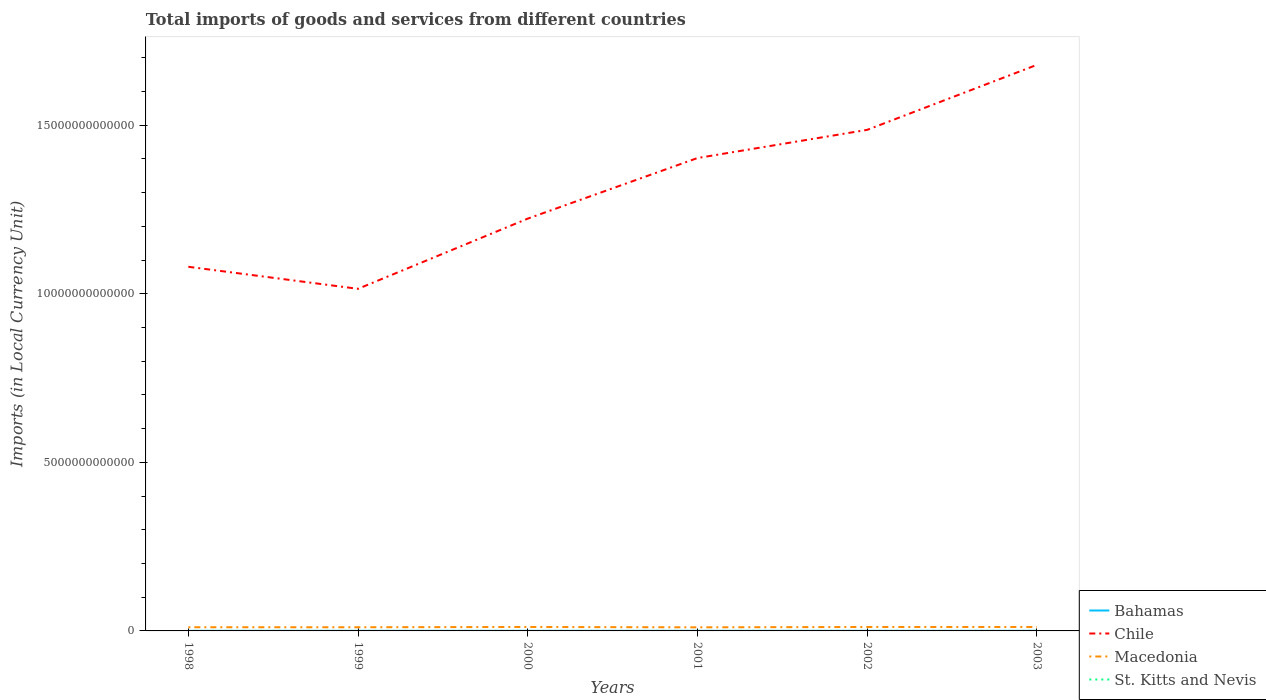How many different coloured lines are there?
Your answer should be compact. 4. Does the line corresponding to St. Kitts and Nevis intersect with the line corresponding to Macedonia?
Provide a short and direct response. No. Is the number of lines equal to the number of legend labels?
Offer a very short reply. Yes. Across all years, what is the maximum Amount of goods and services imports in Bahamas?
Offer a very short reply. 2.60e+09. In which year was the Amount of goods and services imports in Macedonia maximum?
Give a very brief answer. 2001. What is the total Amount of goods and services imports in St. Kitts and Nevis in the graph?
Your answer should be compact. -1.70e+08. What is the difference between the highest and the second highest Amount of goods and services imports in Macedonia?
Make the answer very short. 1.07e+1. Is the Amount of goods and services imports in Chile strictly greater than the Amount of goods and services imports in Macedonia over the years?
Your response must be concise. No. How many years are there in the graph?
Provide a short and direct response. 6. What is the difference between two consecutive major ticks on the Y-axis?
Offer a very short reply. 5.00e+12. Are the values on the major ticks of Y-axis written in scientific E-notation?
Your answer should be very brief. No. How are the legend labels stacked?
Your answer should be very brief. Vertical. What is the title of the graph?
Your response must be concise. Total imports of goods and services from different countries. Does "American Samoa" appear as one of the legend labels in the graph?
Provide a short and direct response. No. What is the label or title of the Y-axis?
Offer a very short reply. Imports (in Local Currency Unit). What is the Imports (in Local Currency Unit) in Bahamas in 1998?
Offer a very short reply. 2.60e+09. What is the Imports (in Local Currency Unit) of Chile in 1998?
Your answer should be very brief. 1.08e+13. What is the Imports (in Local Currency Unit) in Macedonia in 1998?
Offer a terse response. 1.09e+11. What is the Imports (in Local Currency Unit) of St. Kitts and Nevis in 1998?
Offer a terse response. 5.21e+08. What is the Imports (in Local Currency Unit) in Bahamas in 1999?
Your answer should be very brief. 2.66e+09. What is the Imports (in Local Currency Unit) in Chile in 1999?
Provide a short and direct response. 1.01e+13. What is the Imports (in Local Currency Unit) of Macedonia in 1999?
Ensure brevity in your answer.  1.09e+11. What is the Imports (in Local Currency Unit) of St. Kitts and Nevis in 1999?
Provide a short and direct response. 5.54e+08. What is the Imports (in Local Currency Unit) in Bahamas in 2000?
Offer a very short reply. 2.96e+09. What is the Imports (in Local Currency Unit) of Chile in 2000?
Ensure brevity in your answer.  1.22e+13. What is the Imports (in Local Currency Unit) in Macedonia in 2000?
Your answer should be very brief. 1.17e+11. What is the Imports (in Local Currency Unit) of St. Kitts and Nevis in 2000?
Ensure brevity in your answer.  6.72e+08. What is the Imports (in Local Currency Unit) of Bahamas in 2001?
Provide a succinct answer. 2.82e+09. What is the Imports (in Local Currency Unit) of Chile in 2001?
Your response must be concise. 1.40e+13. What is the Imports (in Local Currency Unit) of Macedonia in 2001?
Keep it short and to the point. 1.07e+11. What is the Imports (in Local Currency Unit) of St. Kitts and Nevis in 2001?
Give a very brief answer. 6.53e+08. What is the Imports (in Local Currency Unit) of Bahamas in 2002?
Your response must be concise. 2.67e+09. What is the Imports (in Local Currency Unit) of Chile in 2002?
Offer a very short reply. 1.49e+13. What is the Imports (in Local Currency Unit) in Macedonia in 2002?
Your response must be concise. 1.17e+11. What is the Imports (in Local Currency Unit) of St. Kitts and Nevis in 2002?
Provide a succinct answer. 6.92e+08. What is the Imports (in Local Currency Unit) in Bahamas in 2003?
Provide a short and direct response. 2.76e+09. What is the Imports (in Local Currency Unit) of Chile in 2003?
Ensure brevity in your answer.  1.68e+13. What is the Imports (in Local Currency Unit) of Macedonia in 2003?
Your response must be concise. 1.17e+11. What is the Imports (in Local Currency Unit) of St. Kitts and Nevis in 2003?
Provide a succinct answer. 6.91e+08. Across all years, what is the maximum Imports (in Local Currency Unit) of Bahamas?
Give a very brief answer. 2.96e+09. Across all years, what is the maximum Imports (in Local Currency Unit) in Chile?
Offer a terse response. 1.68e+13. Across all years, what is the maximum Imports (in Local Currency Unit) in Macedonia?
Offer a terse response. 1.17e+11. Across all years, what is the maximum Imports (in Local Currency Unit) of St. Kitts and Nevis?
Your response must be concise. 6.92e+08. Across all years, what is the minimum Imports (in Local Currency Unit) of Bahamas?
Give a very brief answer. 2.60e+09. Across all years, what is the minimum Imports (in Local Currency Unit) in Chile?
Provide a short and direct response. 1.01e+13. Across all years, what is the minimum Imports (in Local Currency Unit) in Macedonia?
Offer a very short reply. 1.07e+11. Across all years, what is the minimum Imports (in Local Currency Unit) in St. Kitts and Nevis?
Give a very brief answer. 5.21e+08. What is the total Imports (in Local Currency Unit) in Bahamas in the graph?
Your answer should be very brief. 1.65e+1. What is the total Imports (in Local Currency Unit) in Chile in the graph?
Give a very brief answer. 7.89e+13. What is the total Imports (in Local Currency Unit) of Macedonia in the graph?
Keep it short and to the point. 6.76e+11. What is the total Imports (in Local Currency Unit) in St. Kitts and Nevis in the graph?
Offer a terse response. 3.78e+09. What is the difference between the Imports (in Local Currency Unit) of Bahamas in 1998 and that in 1999?
Make the answer very short. -6.41e+07. What is the difference between the Imports (in Local Currency Unit) in Chile in 1998 and that in 1999?
Ensure brevity in your answer.  6.54e+11. What is the difference between the Imports (in Local Currency Unit) of Macedonia in 1998 and that in 1999?
Offer a very short reply. 3.48e+08. What is the difference between the Imports (in Local Currency Unit) of St. Kitts and Nevis in 1998 and that in 1999?
Your response must be concise. -3.30e+07. What is the difference between the Imports (in Local Currency Unit) of Bahamas in 1998 and that in 2000?
Make the answer very short. -3.68e+08. What is the difference between the Imports (in Local Currency Unit) in Chile in 1998 and that in 2000?
Provide a succinct answer. -1.43e+12. What is the difference between the Imports (in Local Currency Unit) in Macedonia in 1998 and that in 2000?
Your answer should be very brief. -8.04e+09. What is the difference between the Imports (in Local Currency Unit) of St. Kitts and Nevis in 1998 and that in 2000?
Keep it short and to the point. -1.50e+08. What is the difference between the Imports (in Local Currency Unit) in Bahamas in 1998 and that in 2001?
Make the answer very short. -2.24e+08. What is the difference between the Imports (in Local Currency Unit) of Chile in 1998 and that in 2001?
Your answer should be very brief. -3.23e+12. What is the difference between the Imports (in Local Currency Unit) in Macedonia in 1998 and that in 2001?
Offer a very short reply. 2.64e+09. What is the difference between the Imports (in Local Currency Unit) of St. Kitts and Nevis in 1998 and that in 2001?
Your answer should be very brief. -1.32e+08. What is the difference between the Imports (in Local Currency Unit) in Bahamas in 1998 and that in 2002?
Provide a succinct answer. -7.56e+07. What is the difference between the Imports (in Local Currency Unit) in Chile in 1998 and that in 2002?
Your answer should be very brief. -4.06e+12. What is the difference between the Imports (in Local Currency Unit) of Macedonia in 1998 and that in 2002?
Provide a short and direct response. -7.61e+09. What is the difference between the Imports (in Local Currency Unit) of St. Kitts and Nevis in 1998 and that in 2002?
Your answer should be compact. -1.71e+08. What is the difference between the Imports (in Local Currency Unit) of Bahamas in 1998 and that in 2003?
Your response must be concise. -1.62e+08. What is the difference between the Imports (in Local Currency Unit) of Chile in 1998 and that in 2003?
Give a very brief answer. -5.99e+12. What is the difference between the Imports (in Local Currency Unit) in Macedonia in 1998 and that in 2003?
Keep it short and to the point. -7.29e+09. What is the difference between the Imports (in Local Currency Unit) in St. Kitts and Nevis in 1998 and that in 2003?
Ensure brevity in your answer.  -1.70e+08. What is the difference between the Imports (in Local Currency Unit) of Bahamas in 1999 and that in 2000?
Provide a short and direct response. -3.04e+08. What is the difference between the Imports (in Local Currency Unit) of Chile in 1999 and that in 2000?
Offer a terse response. -2.08e+12. What is the difference between the Imports (in Local Currency Unit) in Macedonia in 1999 and that in 2000?
Your response must be concise. -8.39e+09. What is the difference between the Imports (in Local Currency Unit) in St. Kitts and Nevis in 1999 and that in 2000?
Ensure brevity in your answer.  -1.17e+08. What is the difference between the Imports (in Local Currency Unit) of Bahamas in 1999 and that in 2001?
Offer a terse response. -1.59e+08. What is the difference between the Imports (in Local Currency Unit) in Chile in 1999 and that in 2001?
Your answer should be very brief. -3.88e+12. What is the difference between the Imports (in Local Currency Unit) of Macedonia in 1999 and that in 2001?
Provide a short and direct response. 2.30e+09. What is the difference between the Imports (in Local Currency Unit) in St. Kitts and Nevis in 1999 and that in 2001?
Your response must be concise. -9.87e+07. What is the difference between the Imports (in Local Currency Unit) of Bahamas in 1999 and that in 2002?
Your answer should be very brief. -1.16e+07. What is the difference between the Imports (in Local Currency Unit) of Chile in 1999 and that in 2002?
Your answer should be compact. -4.72e+12. What is the difference between the Imports (in Local Currency Unit) of Macedonia in 1999 and that in 2002?
Your answer should be very brief. -7.96e+09. What is the difference between the Imports (in Local Currency Unit) of St. Kitts and Nevis in 1999 and that in 2002?
Ensure brevity in your answer.  -1.38e+08. What is the difference between the Imports (in Local Currency Unit) of Bahamas in 1999 and that in 2003?
Your response must be concise. -9.82e+07. What is the difference between the Imports (in Local Currency Unit) in Chile in 1999 and that in 2003?
Keep it short and to the point. -6.64e+12. What is the difference between the Imports (in Local Currency Unit) of Macedonia in 1999 and that in 2003?
Offer a very short reply. -7.64e+09. What is the difference between the Imports (in Local Currency Unit) of St. Kitts and Nevis in 1999 and that in 2003?
Your answer should be compact. -1.36e+08. What is the difference between the Imports (in Local Currency Unit) in Bahamas in 2000 and that in 2001?
Keep it short and to the point. 1.44e+08. What is the difference between the Imports (in Local Currency Unit) in Chile in 2000 and that in 2001?
Keep it short and to the point. -1.80e+12. What is the difference between the Imports (in Local Currency Unit) of Macedonia in 2000 and that in 2001?
Provide a succinct answer. 1.07e+1. What is the difference between the Imports (in Local Currency Unit) of St. Kitts and Nevis in 2000 and that in 2001?
Provide a succinct answer. 1.87e+07. What is the difference between the Imports (in Local Currency Unit) of Bahamas in 2000 and that in 2002?
Offer a very short reply. 2.92e+08. What is the difference between the Imports (in Local Currency Unit) in Chile in 2000 and that in 2002?
Your response must be concise. -2.63e+12. What is the difference between the Imports (in Local Currency Unit) of Macedonia in 2000 and that in 2002?
Give a very brief answer. 4.31e+08. What is the difference between the Imports (in Local Currency Unit) of St. Kitts and Nevis in 2000 and that in 2002?
Your answer should be compact. -2.04e+07. What is the difference between the Imports (in Local Currency Unit) in Bahamas in 2000 and that in 2003?
Give a very brief answer. 2.05e+08. What is the difference between the Imports (in Local Currency Unit) of Chile in 2000 and that in 2003?
Keep it short and to the point. -4.56e+12. What is the difference between the Imports (in Local Currency Unit) of Macedonia in 2000 and that in 2003?
Ensure brevity in your answer.  7.46e+08. What is the difference between the Imports (in Local Currency Unit) of St. Kitts and Nevis in 2000 and that in 2003?
Ensure brevity in your answer.  -1.91e+07. What is the difference between the Imports (in Local Currency Unit) of Bahamas in 2001 and that in 2002?
Make the answer very short. 1.48e+08. What is the difference between the Imports (in Local Currency Unit) in Chile in 2001 and that in 2002?
Ensure brevity in your answer.  -8.36e+11. What is the difference between the Imports (in Local Currency Unit) of Macedonia in 2001 and that in 2002?
Keep it short and to the point. -1.03e+1. What is the difference between the Imports (in Local Currency Unit) of St. Kitts and Nevis in 2001 and that in 2002?
Provide a succinct answer. -3.91e+07. What is the difference between the Imports (in Local Currency Unit) in Bahamas in 2001 and that in 2003?
Make the answer very short. 6.12e+07. What is the difference between the Imports (in Local Currency Unit) of Chile in 2001 and that in 2003?
Ensure brevity in your answer.  -2.76e+12. What is the difference between the Imports (in Local Currency Unit) in Macedonia in 2001 and that in 2003?
Your answer should be very brief. -9.94e+09. What is the difference between the Imports (in Local Currency Unit) in St. Kitts and Nevis in 2001 and that in 2003?
Your response must be concise. -3.78e+07. What is the difference between the Imports (in Local Currency Unit) of Bahamas in 2002 and that in 2003?
Your response must be concise. -8.67e+07. What is the difference between the Imports (in Local Currency Unit) in Chile in 2002 and that in 2003?
Keep it short and to the point. -1.93e+12. What is the difference between the Imports (in Local Currency Unit) of Macedonia in 2002 and that in 2003?
Keep it short and to the point. 3.15e+08. What is the difference between the Imports (in Local Currency Unit) in St. Kitts and Nevis in 2002 and that in 2003?
Your answer should be very brief. 1.28e+06. What is the difference between the Imports (in Local Currency Unit) of Bahamas in 1998 and the Imports (in Local Currency Unit) of Chile in 1999?
Provide a short and direct response. -1.01e+13. What is the difference between the Imports (in Local Currency Unit) of Bahamas in 1998 and the Imports (in Local Currency Unit) of Macedonia in 1999?
Your answer should be very brief. -1.06e+11. What is the difference between the Imports (in Local Currency Unit) of Bahamas in 1998 and the Imports (in Local Currency Unit) of St. Kitts and Nevis in 1999?
Make the answer very short. 2.04e+09. What is the difference between the Imports (in Local Currency Unit) in Chile in 1998 and the Imports (in Local Currency Unit) in Macedonia in 1999?
Make the answer very short. 1.07e+13. What is the difference between the Imports (in Local Currency Unit) of Chile in 1998 and the Imports (in Local Currency Unit) of St. Kitts and Nevis in 1999?
Provide a short and direct response. 1.08e+13. What is the difference between the Imports (in Local Currency Unit) of Macedonia in 1998 and the Imports (in Local Currency Unit) of St. Kitts and Nevis in 1999?
Provide a succinct answer. 1.09e+11. What is the difference between the Imports (in Local Currency Unit) in Bahamas in 1998 and the Imports (in Local Currency Unit) in Chile in 2000?
Your response must be concise. -1.22e+13. What is the difference between the Imports (in Local Currency Unit) of Bahamas in 1998 and the Imports (in Local Currency Unit) of Macedonia in 2000?
Ensure brevity in your answer.  -1.15e+11. What is the difference between the Imports (in Local Currency Unit) in Bahamas in 1998 and the Imports (in Local Currency Unit) in St. Kitts and Nevis in 2000?
Ensure brevity in your answer.  1.92e+09. What is the difference between the Imports (in Local Currency Unit) in Chile in 1998 and the Imports (in Local Currency Unit) in Macedonia in 2000?
Make the answer very short. 1.07e+13. What is the difference between the Imports (in Local Currency Unit) in Chile in 1998 and the Imports (in Local Currency Unit) in St. Kitts and Nevis in 2000?
Provide a short and direct response. 1.08e+13. What is the difference between the Imports (in Local Currency Unit) in Macedonia in 1998 and the Imports (in Local Currency Unit) in St. Kitts and Nevis in 2000?
Keep it short and to the point. 1.09e+11. What is the difference between the Imports (in Local Currency Unit) of Bahamas in 1998 and the Imports (in Local Currency Unit) of Chile in 2001?
Give a very brief answer. -1.40e+13. What is the difference between the Imports (in Local Currency Unit) in Bahamas in 1998 and the Imports (in Local Currency Unit) in Macedonia in 2001?
Make the answer very short. -1.04e+11. What is the difference between the Imports (in Local Currency Unit) in Bahamas in 1998 and the Imports (in Local Currency Unit) in St. Kitts and Nevis in 2001?
Provide a succinct answer. 1.94e+09. What is the difference between the Imports (in Local Currency Unit) of Chile in 1998 and the Imports (in Local Currency Unit) of Macedonia in 2001?
Provide a short and direct response. 1.07e+13. What is the difference between the Imports (in Local Currency Unit) of Chile in 1998 and the Imports (in Local Currency Unit) of St. Kitts and Nevis in 2001?
Your response must be concise. 1.08e+13. What is the difference between the Imports (in Local Currency Unit) in Macedonia in 1998 and the Imports (in Local Currency Unit) in St. Kitts and Nevis in 2001?
Keep it short and to the point. 1.09e+11. What is the difference between the Imports (in Local Currency Unit) in Bahamas in 1998 and the Imports (in Local Currency Unit) in Chile in 2002?
Offer a terse response. -1.49e+13. What is the difference between the Imports (in Local Currency Unit) of Bahamas in 1998 and the Imports (in Local Currency Unit) of Macedonia in 2002?
Ensure brevity in your answer.  -1.14e+11. What is the difference between the Imports (in Local Currency Unit) of Bahamas in 1998 and the Imports (in Local Currency Unit) of St. Kitts and Nevis in 2002?
Give a very brief answer. 1.90e+09. What is the difference between the Imports (in Local Currency Unit) of Chile in 1998 and the Imports (in Local Currency Unit) of Macedonia in 2002?
Keep it short and to the point. 1.07e+13. What is the difference between the Imports (in Local Currency Unit) in Chile in 1998 and the Imports (in Local Currency Unit) in St. Kitts and Nevis in 2002?
Provide a succinct answer. 1.08e+13. What is the difference between the Imports (in Local Currency Unit) of Macedonia in 1998 and the Imports (in Local Currency Unit) of St. Kitts and Nevis in 2002?
Make the answer very short. 1.09e+11. What is the difference between the Imports (in Local Currency Unit) in Bahamas in 1998 and the Imports (in Local Currency Unit) in Chile in 2003?
Make the answer very short. -1.68e+13. What is the difference between the Imports (in Local Currency Unit) of Bahamas in 1998 and the Imports (in Local Currency Unit) of Macedonia in 2003?
Provide a succinct answer. -1.14e+11. What is the difference between the Imports (in Local Currency Unit) of Bahamas in 1998 and the Imports (in Local Currency Unit) of St. Kitts and Nevis in 2003?
Offer a terse response. 1.91e+09. What is the difference between the Imports (in Local Currency Unit) of Chile in 1998 and the Imports (in Local Currency Unit) of Macedonia in 2003?
Your answer should be very brief. 1.07e+13. What is the difference between the Imports (in Local Currency Unit) of Chile in 1998 and the Imports (in Local Currency Unit) of St. Kitts and Nevis in 2003?
Ensure brevity in your answer.  1.08e+13. What is the difference between the Imports (in Local Currency Unit) of Macedonia in 1998 and the Imports (in Local Currency Unit) of St. Kitts and Nevis in 2003?
Your answer should be very brief. 1.09e+11. What is the difference between the Imports (in Local Currency Unit) in Bahamas in 1999 and the Imports (in Local Currency Unit) in Chile in 2000?
Your answer should be compact. -1.22e+13. What is the difference between the Imports (in Local Currency Unit) of Bahamas in 1999 and the Imports (in Local Currency Unit) of Macedonia in 2000?
Provide a short and direct response. -1.15e+11. What is the difference between the Imports (in Local Currency Unit) in Bahamas in 1999 and the Imports (in Local Currency Unit) in St. Kitts and Nevis in 2000?
Give a very brief answer. 1.99e+09. What is the difference between the Imports (in Local Currency Unit) in Chile in 1999 and the Imports (in Local Currency Unit) in Macedonia in 2000?
Your answer should be very brief. 1.00e+13. What is the difference between the Imports (in Local Currency Unit) in Chile in 1999 and the Imports (in Local Currency Unit) in St. Kitts and Nevis in 2000?
Keep it short and to the point. 1.01e+13. What is the difference between the Imports (in Local Currency Unit) in Macedonia in 1999 and the Imports (in Local Currency Unit) in St. Kitts and Nevis in 2000?
Your answer should be very brief. 1.08e+11. What is the difference between the Imports (in Local Currency Unit) in Bahamas in 1999 and the Imports (in Local Currency Unit) in Chile in 2001?
Make the answer very short. -1.40e+13. What is the difference between the Imports (in Local Currency Unit) of Bahamas in 1999 and the Imports (in Local Currency Unit) of Macedonia in 2001?
Keep it short and to the point. -1.04e+11. What is the difference between the Imports (in Local Currency Unit) of Bahamas in 1999 and the Imports (in Local Currency Unit) of St. Kitts and Nevis in 2001?
Ensure brevity in your answer.  2.01e+09. What is the difference between the Imports (in Local Currency Unit) of Chile in 1999 and the Imports (in Local Currency Unit) of Macedonia in 2001?
Offer a very short reply. 1.00e+13. What is the difference between the Imports (in Local Currency Unit) of Chile in 1999 and the Imports (in Local Currency Unit) of St. Kitts and Nevis in 2001?
Keep it short and to the point. 1.01e+13. What is the difference between the Imports (in Local Currency Unit) in Macedonia in 1999 and the Imports (in Local Currency Unit) in St. Kitts and Nevis in 2001?
Make the answer very short. 1.08e+11. What is the difference between the Imports (in Local Currency Unit) of Bahamas in 1999 and the Imports (in Local Currency Unit) of Chile in 2002?
Your answer should be very brief. -1.49e+13. What is the difference between the Imports (in Local Currency Unit) in Bahamas in 1999 and the Imports (in Local Currency Unit) in Macedonia in 2002?
Ensure brevity in your answer.  -1.14e+11. What is the difference between the Imports (in Local Currency Unit) of Bahamas in 1999 and the Imports (in Local Currency Unit) of St. Kitts and Nevis in 2002?
Offer a terse response. 1.97e+09. What is the difference between the Imports (in Local Currency Unit) in Chile in 1999 and the Imports (in Local Currency Unit) in Macedonia in 2002?
Offer a very short reply. 1.00e+13. What is the difference between the Imports (in Local Currency Unit) in Chile in 1999 and the Imports (in Local Currency Unit) in St. Kitts and Nevis in 2002?
Offer a terse response. 1.01e+13. What is the difference between the Imports (in Local Currency Unit) in Macedonia in 1999 and the Imports (in Local Currency Unit) in St. Kitts and Nevis in 2002?
Provide a short and direct response. 1.08e+11. What is the difference between the Imports (in Local Currency Unit) in Bahamas in 1999 and the Imports (in Local Currency Unit) in Chile in 2003?
Ensure brevity in your answer.  -1.68e+13. What is the difference between the Imports (in Local Currency Unit) in Bahamas in 1999 and the Imports (in Local Currency Unit) in Macedonia in 2003?
Your answer should be compact. -1.14e+11. What is the difference between the Imports (in Local Currency Unit) of Bahamas in 1999 and the Imports (in Local Currency Unit) of St. Kitts and Nevis in 2003?
Your answer should be very brief. 1.97e+09. What is the difference between the Imports (in Local Currency Unit) in Chile in 1999 and the Imports (in Local Currency Unit) in Macedonia in 2003?
Make the answer very short. 1.00e+13. What is the difference between the Imports (in Local Currency Unit) in Chile in 1999 and the Imports (in Local Currency Unit) in St. Kitts and Nevis in 2003?
Your response must be concise. 1.01e+13. What is the difference between the Imports (in Local Currency Unit) of Macedonia in 1999 and the Imports (in Local Currency Unit) of St. Kitts and Nevis in 2003?
Provide a succinct answer. 1.08e+11. What is the difference between the Imports (in Local Currency Unit) in Bahamas in 2000 and the Imports (in Local Currency Unit) in Chile in 2001?
Offer a very short reply. -1.40e+13. What is the difference between the Imports (in Local Currency Unit) in Bahamas in 2000 and the Imports (in Local Currency Unit) in Macedonia in 2001?
Give a very brief answer. -1.04e+11. What is the difference between the Imports (in Local Currency Unit) of Bahamas in 2000 and the Imports (in Local Currency Unit) of St. Kitts and Nevis in 2001?
Offer a very short reply. 2.31e+09. What is the difference between the Imports (in Local Currency Unit) of Chile in 2000 and the Imports (in Local Currency Unit) of Macedonia in 2001?
Your answer should be compact. 1.21e+13. What is the difference between the Imports (in Local Currency Unit) of Chile in 2000 and the Imports (in Local Currency Unit) of St. Kitts and Nevis in 2001?
Make the answer very short. 1.22e+13. What is the difference between the Imports (in Local Currency Unit) in Macedonia in 2000 and the Imports (in Local Currency Unit) in St. Kitts and Nevis in 2001?
Offer a very short reply. 1.17e+11. What is the difference between the Imports (in Local Currency Unit) in Bahamas in 2000 and the Imports (in Local Currency Unit) in Chile in 2002?
Your answer should be very brief. -1.49e+13. What is the difference between the Imports (in Local Currency Unit) in Bahamas in 2000 and the Imports (in Local Currency Unit) in Macedonia in 2002?
Offer a terse response. -1.14e+11. What is the difference between the Imports (in Local Currency Unit) in Bahamas in 2000 and the Imports (in Local Currency Unit) in St. Kitts and Nevis in 2002?
Your answer should be compact. 2.27e+09. What is the difference between the Imports (in Local Currency Unit) in Chile in 2000 and the Imports (in Local Currency Unit) in Macedonia in 2002?
Provide a succinct answer. 1.21e+13. What is the difference between the Imports (in Local Currency Unit) in Chile in 2000 and the Imports (in Local Currency Unit) in St. Kitts and Nevis in 2002?
Provide a succinct answer. 1.22e+13. What is the difference between the Imports (in Local Currency Unit) in Macedonia in 2000 and the Imports (in Local Currency Unit) in St. Kitts and Nevis in 2002?
Provide a short and direct response. 1.17e+11. What is the difference between the Imports (in Local Currency Unit) of Bahamas in 2000 and the Imports (in Local Currency Unit) of Chile in 2003?
Ensure brevity in your answer.  -1.68e+13. What is the difference between the Imports (in Local Currency Unit) of Bahamas in 2000 and the Imports (in Local Currency Unit) of Macedonia in 2003?
Your answer should be compact. -1.14e+11. What is the difference between the Imports (in Local Currency Unit) in Bahamas in 2000 and the Imports (in Local Currency Unit) in St. Kitts and Nevis in 2003?
Give a very brief answer. 2.27e+09. What is the difference between the Imports (in Local Currency Unit) of Chile in 2000 and the Imports (in Local Currency Unit) of Macedonia in 2003?
Give a very brief answer. 1.21e+13. What is the difference between the Imports (in Local Currency Unit) in Chile in 2000 and the Imports (in Local Currency Unit) in St. Kitts and Nevis in 2003?
Offer a very short reply. 1.22e+13. What is the difference between the Imports (in Local Currency Unit) in Macedonia in 2000 and the Imports (in Local Currency Unit) in St. Kitts and Nevis in 2003?
Keep it short and to the point. 1.17e+11. What is the difference between the Imports (in Local Currency Unit) of Bahamas in 2001 and the Imports (in Local Currency Unit) of Chile in 2002?
Your answer should be compact. -1.49e+13. What is the difference between the Imports (in Local Currency Unit) of Bahamas in 2001 and the Imports (in Local Currency Unit) of Macedonia in 2002?
Offer a very short reply. -1.14e+11. What is the difference between the Imports (in Local Currency Unit) of Bahamas in 2001 and the Imports (in Local Currency Unit) of St. Kitts and Nevis in 2002?
Give a very brief answer. 2.13e+09. What is the difference between the Imports (in Local Currency Unit) in Chile in 2001 and the Imports (in Local Currency Unit) in Macedonia in 2002?
Your answer should be compact. 1.39e+13. What is the difference between the Imports (in Local Currency Unit) of Chile in 2001 and the Imports (in Local Currency Unit) of St. Kitts and Nevis in 2002?
Make the answer very short. 1.40e+13. What is the difference between the Imports (in Local Currency Unit) in Macedonia in 2001 and the Imports (in Local Currency Unit) in St. Kitts and Nevis in 2002?
Your answer should be very brief. 1.06e+11. What is the difference between the Imports (in Local Currency Unit) of Bahamas in 2001 and the Imports (in Local Currency Unit) of Chile in 2003?
Your response must be concise. -1.68e+13. What is the difference between the Imports (in Local Currency Unit) in Bahamas in 2001 and the Imports (in Local Currency Unit) in Macedonia in 2003?
Your response must be concise. -1.14e+11. What is the difference between the Imports (in Local Currency Unit) of Bahamas in 2001 and the Imports (in Local Currency Unit) of St. Kitts and Nevis in 2003?
Provide a succinct answer. 2.13e+09. What is the difference between the Imports (in Local Currency Unit) in Chile in 2001 and the Imports (in Local Currency Unit) in Macedonia in 2003?
Make the answer very short. 1.39e+13. What is the difference between the Imports (in Local Currency Unit) in Chile in 2001 and the Imports (in Local Currency Unit) in St. Kitts and Nevis in 2003?
Give a very brief answer. 1.40e+13. What is the difference between the Imports (in Local Currency Unit) in Macedonia in 2001 and the Imports (in Local Currency Unit) in St. Kitts and Nevis in 2003?
Your answer should be very brief. 1.06e+11. What is the difference between the Imports (in Local Currency Unit) in Bahamas in 2002 and the Imports (in Local Currency Unit) in Chile in 2003?
Make the answer very short. -1.68e+13. What is the difference between the Imports (in Local Currency Unit) of Bahamas in 2002 and the Imports (in Local Currency Unit) of Macedonia in 2003?
Your answer should be very brief. -1.14e+11. What is the difference between the Imports (in Local Currency Unit) in Bahamas in 2002 and the Imports (in Local Currency Unit) in St. Kitts and Nevis in 2003?
Provide a short and direct response. 1.98e+09. What is the difference between the Imports (in Local Currency Unit) in Chile in 2002 and the Imports (in Local Currency Unit) in Macedonia in 2003?
Give a very brief answer. 1.47e+13. What is the difference between the Imports (in Local Currency Unit) of Chile in 2002 and the Imports (in Local Currency Unit) of St. Kitts and Nevis in 2003?
Offer a very short reply. 1.49e+13. What is the difference between the Imports (in Local Currency Unit) of Macedonia in 2002 and the Imports (in Local Currency Unit) of St. Kitts and Nevis in 2003?
Your response must be concise. 1.16e+11. What is the average Imports (in Local Currency Unit) in Bahamas per year?
Give a very brief answer. 2.75e+09. What is the average Imports (in Local Currency Unit) of Chile per year?
Keep it short and to the point. 1.31e+13. What is the average Imports (in Local Currency Unit) of Macedonia per year?
Keep it short and to the point. 1.13e+11. What is the average Imports (in Local Currency Unit) of St. Kitts and Nevis per year?
Provide a succinct answer. 6.30e+08. In the year 1998, what is the difference between the Imports (in Local Currency Unit) in Bahamas and Imports (in Local Currency Unit) in Chile?
Make the answer very short. -1.08e+13. In the year 1998, what is the difference between the Imports (in Local Currency Unit) of Bahamas and Imports (in Local Currency Unit) of Macedonia?
Your answer should be very brief. -1.07e+11. In the year 1998, what is the difference between the Imports (in Local Currency Unit) of Bahamas and Imports (in Local Currency Unit) of St. Kitts and Nevis?
Provide a short and direct response. 2.08e+09. In the year 1998, what is the difference between the Imports (in Local Currency Unit) of Chile and Imports (in Local Currency Unit) of Macedonia?
Ensure brevity in your answer.  1.07e+13. In the year 1998, what is the difference between the Imports (in Local Currency Unit) in Chile and Imports (in Local Currency Unit) in St. Kitts and Nevis?
Make the answer very short. 1.08e+13. In the year 1998, what is the difference between the Imports (in Local Currency Unit) of Macedonia and Imports (in Local Currency Unit) of St. Kitts and Nevis?
Your answer should be compact. 1.09e+11. In the year 1999, what is the difference between the Imports (in Local Currency Unit) of Bahamas and Imports (in Local Currency Unit) of Chile?
Ensure brevity in your answer.  -1.01e+13. In the year 1999, what is the difference between the Imports (in Local Currency Unit) in Bahamas and Imports (in Local Currency Unit) in Macedonia?
Offer a very short reply. -1.06e+11. In the year 1999, what is the difference between the Imports (in Local Currency Unit) in Bahamas and Imports (in Local Currency Unit) in St. Kitts and Nevis?
Your answer should be very brief. 2.11e+09. In the year 1999, what is the difference between the Imports (in Local Currency Unit) of Chile and Imports (in Local Currency Unit) of Macedonia?
Give a very brief answer. 1.00e+13. In the year 1999, what is the difference between the Imports (in Local Currency Unit) in Chile and Imports (in Local Currency Unit) in St. Kitts and Nevis?
Offer a very short reply. 1.01e+13. In the year 1999, what is the difference between the Imports (in Local Currency Unit) of Macedonia and Imports (in Local Currency Unit) of St. Kitts and Nevis?
Offer a very short reply. 1.08e+11. In the year 2000, what is the difference between the Imports (in Local Currency Unit) in Bahamas and Imports (in Local Currency Unit) in Chile?
Give a very brief answer. -1.22e+13. In the year 2000, what is the difference between the Imports (in Local Currency Unit) in Bahamas and Imports (in Local Currency Unit) in Macedonia?
Your response must be concise. -1.14e+11. In the year 2000, what is the difference between the Imports (in Local Currency Unit) in Bahamas and Imports (in Local Currency Unit) in St. Kitts and Nevis?
Your response must be concise. 2.29e+09. In the year 2000, what is the difference between the Imports (in Local Currency Unit) in Chile and Imports (in Local Currency Unit) in Macedonia?
Provide a succinct answer. 1.21e+13. In the year 2000, what is the difference between the Imports (in Local Currency Unit) in Chile and Imports (in Local Currency Unit) in St. Kitts and Nevis?
Offer a very short reply. 1.22e+13. In the year 2000, what is the difference between the Imports (in Local Currency Unit) in Macedonia and Imports (in Local Currency Unit) in St. Kitts and Nevis?
Offer a terse response. 1.17e+11. In the year 2001, what is the difference between the Imports (in Local Currency Unit) of Bahamas and Imports (in Local Currency Unit) of Chile?
Your answer should be compact. -1.40e+13. In the year 2001, what is the difference between the Imports (in Local Currency Unit) in Bahamas and Imports (in Local Currency Unit) in Macedonia?
Your answer should be compact. -1.04e+11. In the year 2001, what is the difference between the Imports (in Local Currency Unit) of Bahamas and Imports (in Local Currency Unit) of St. Kitts and Nevis?
Give a very brief answer. 2.17e+09. In the year 2001, what is the difference between the Imports (in Local Currency Unit) of Chile and Imports (in Local Currency Unit) of Macedonia?
Your answer should be very brief. 1.39e+13. In the year 2001, what is the difference between the Imports (in Local Currency Unit) in Chile and Imports (in Local Currency Unit) in St. Kitts and Nevis?
Make the answer very short. 1.40e+13. In the year 2001, what is the difference between the Imports (in Local Currency Unit) in Macedonia and Imports (in Local Currency Unit) in St. Kitts and Nevis?
Keep it short and to the point. 1.06e+11. In the year 2002, what is the difference between the Imports (in Local Currency Unit) in Bahamas and Imports (in Local Currency Unit) in Chile?
Provide a short and direct response. -1.49e+13. In the year 2002, what is the difference between the Imports (in Local Currency Unit) of Bahamas and Imports (in Local Currency Unit) of Macedonia?
Your answer should be very brief. -1.14e+11. In the year 2002, what is the difference between the Imports (in Local Currency Unit) of Bahamas and Imports (in Local Currency Unit) of St. Kitts and Nevis?
Your response must be concise. 1.98e+09. In the year 2002, what is the difference between the Imports (in Local Currency Unit) in Chile and Imports (in Local Currency Unit) in Macedonia?
Keep it short and to the point. 1.47e+13. In the year 2002, what is the difference between the Imports (in Local Currency Unit) of Chile and Imports (in Local Currency Unit) of St. Kitts and Nevis?
Keep it short and to the point. 1.49e+13. In the year 2002, what is the difference between the Imports (in Local Currency Unit) in Macedonia and Imports (in Local Currency Unit) in St. Kitts and Nevis?
Offer a very short reply. 1.16e+11. In the year 2003, what is the difference between the Imports (in Local Currency Unit) in Bahamas and Imports (in Local Currency Unit) in Chile?
Your answer should be compact. -1.68e+13. In the year 2003, what is the difference between the Imports (in Local Currency Unit) of Bahamas and Imports (in Local Currency Unit) of Macedonia?
Keep it short and to the point. -1.14e+11. In the year 2003, what is the difference between the Imports (in Local Currency Unit) in Bahamas and Imports (in Local Currency Unit) in St. Kitts and Nevis?
Provide a succinct answer. 2.07e+09. In the year 2003, what is the difference between the Imports (in Local Currency Unit) of Chile and Imports (in Local Currency Unit) of Macedonia?
Offer a terse response. 1.67e+13. In the year 2003, what is the difference between the Imports (in Local Currency Unit) in Chile and Imports (in Local Currency Unit) in St. Kitts and Nevis?
Your answer should be very brief. 1.68e+13. In the year 2003, what is the difference between the Imports (in Local Currency Unit) of Macedonia and Imports (in Local Currency Unit) of St. Kitts and Nevis?
Ensure brevity in your answer.  1.16e+11. What is the ratio of the Imports (in Local Currency Unit) in Bahamas in 1998 to that in 1999?
Your answer should be compact. 0.98. What is the ratio of the Imports (in Local Currency Unit) of Chile in 1998 to that in 1999?
Provide a short and direct response. 1.06. What is the ratio of the Imports (in Local Currency Unit) of Macedonia in 1998 to that in 1999?
Your response must be concise. 1. What is the ratio of the Imports (in Local Currency Unit) of St. Kitts and Nevis in 1998 to that in 1999?
Your answer should be very brief. 0.94. What is the ratio of the Imports (in Local Currency Unit) of Bahamas in 1998 to that in 2000?
Make the answer very short. 0.88. What is the ratio of the Imports (in Local Currency Unit) in Chile in 1998 to that in 2000?
Your response must be concise. 0.88. What is the ratio of the Imports (in Local Currency Unit) in Macedonia in 1998 to that in 2000?
Your answer should be compact. 0.93. What is the ratio of the Imports (in Local Currency Unit) in St. Kitts and Nevis in 1998 to that in 2000?
Give a very brief answer. 0.78. What is the ratio of the Imports (in Local Currency Unit) of Bahamas in 1998 to that in 2001?
Your answer should be compact. 0.92. What is the ratio of the Imports (in Local Currency Unit) in Chile in 1998 to that in 2001?
Offer a very short reply. 0.77. What is the ratio of the Imports (in Local Currency Unit) in Macedonia in 1998 to that in 2001?
Your response must be concise. 1.02. What is the ratio of the Imports (in Local Currency Unit) in St. Kitts and Nevis in 1998 to that in 2001?
Make the answer very short. 0.8. What is the ratio of the Imports (in Local Currency Unit) of Bahamas in 1998 to that in 2002?
Ensure brevity in your answer.  0.97. What is the ratio of the Imports (in Local Currency Unit) of Chile in 1998 to that in 2002?
Your answer should be very brief. 0.73. What is the ratio of the Imports (in Local Currency Unit) of Macedonia in 1998 to that in 2002?
Make the answer very short. 0.94. What is the ratio of the Imports (in Local Currency Unit) in St. Kitts and Nevis in 1998 to that in 2002?
Provide a succinct answer. 0.75. What is the ratio of the Imports (in Local Currency Unit) of Chile in 1998 to that in 2003?
Provide a succinct answer. 0.64. What is the ratio of the Imports (in Local Currency Unit) in St. Kitts and Nevis in 1998 to that in 2003?
Provide a short and direct response. 0.75. What is the ratio of the Imports (in Local Currency Unit) of Bahamas in 1999 to that in 2000?
Offer a very short reply. 0.9. What is the ratio of the Imports (in Local Currency Unit) of Chile in 1999 to that in 2000?
Make the answer very short. 0.83. What is the ratio of the Imports (in Local Currency Unit) of Macedonia in 1999 to that in 2000?
Offer a terse response. 0.93. What is the ratio of the Imports (in Local Currency Unit) of St. Kitts and Nevis in 1999 to that in 2000?
Your answer should be very brief. 0.83. What is the ratio of the Imports (in Local Currency Unit) of Bahamas in 1999 to that in 2001?
Keep it short and to the point. 0.94. What is the ratio of the Imports (in Local Currency Unit) of Chile in 1999 to that in 2001?
Offer a very short reply. 0.72. What is the ratio of the Imports (in Local Currency Unit) of Macedonia in 1999 to that in 2001?
Offer a very short reply. 1.02. What is the ratio of the Imports (in Local Currency Unit) of St. Kitts and Nevis in 1999 to that in 2001?
Ensure brevity in your answer.  0.85. What is the ratio of the Imports (in Local Currency Unit) of Bahamas in 1999 to that in 2002?
Provide a succinct answer. 1. What is the ratio of the Imports (in Local Currency Unit) in Chile in 1999 to that in 2002?
Provide a succinct answer. 0.68. What is the ratio of the Imports (in Local Currency Unit) in Macedonia in 1999 to that in 2002?
Your answer should be compact. 0.93. What is the ratio of the Imports (in Local Currency Unit) of St. Kitts and Nevis in 1999 to that in 2002?
Offer a very short reply. 0.8. What is the ratio of the Imports (in Local Currency Unit) in Bahamas in 1999 to that in 2003?
Make the answer very short. 0.96. What is the ratio of the Imports (in Local Currency Unit) of Chile in 1999 to that in 2003?
Make the answer very short. 0.6. What is the ratio of the Imports (in Local Currency Unit) of Macedonia in 1999 to that in 2003?
Offer a terse response. 0.93. What is the ratio of the Imports (in Local Currency Unit) of St. Kitts and Nevis in 1999 to that in 2003?
Ensure brevity in your answer.  0.8. What is the ratio of the Imports (in Local Currency Unit) of Bahamas in 2000 to that in 2001?
Make the answer very short. 1.05. What is the ratio of the Imports (in Local Currency Unit) in Chile in 2000 to that in 2001?
Your answer should be very brief. 0.87. What is the ratio of the Imports (in Local Currency Unit) of Macedonia in 2000 to that in 2001?
Your response must be concise. 1.1. What is the ratio of the Imports (in Local Currency Unit) of St. Kitts and Nevis in 2000 to that in 2001?
Ensure brevity in your answer.  1.03. What is the ratio of the Imports (in Local Currency Unit) of Bahamas in 2000 to that in 2002?
Provide a short and direct response. 1.11. What is the ratio of the Imports (in Local Currency Unit) of Chile in 2000 to that in 2002?
Offer a very short reply. 0.82. What is the ratio of the Imports (in Local Currency Unit) in Macedonia in 2000 to that in 2002?
Provide a short and direct response. 1. What is the ratio of the Imports (in Local Currency Unit) in St. Kitts and Nevis in 2000 to that in 2002?
Your response must be concise. 0.97. What is the ratio of the Imports (in Local Currency Unit) in Bahamas in 2000 to that in 2003?
Provide a succinct answer. 1.07. What is the ratio of the Imports (in Local Currency Unit) of Chile in 2000 to that in 2003?
Give a very brief answer. 0.73. What is the ratio of the Imports (in Local Currency Unit) in Macedonia in 2000 to that in 2003?
Keep it short and to the point. 1.01. What is the ratio of the Imports (in Local Currency Unit) in St. Kitts and Nevis in 2000 to that in 2003?
Your answer should be compact. 0.97. What is the ratio of the Imports (in Local Currency Unit) of Bahamas in 2001 to that in 2002?
Your answer should be very brief. 1.06. What is the ratio of the Imports (in Local Currency Unit) in Chile in 2001 to that in 2002?
Give a very brief answer. 0.94. What is the ratio of the Imports (in Local Currency Unit) of Macedonia in 2001 to that in 2002?
Make the answer very short. 0.91. What is the ratio of the Imports (in Local Currency Unit) of St. Kitts and Nevis in 2001 to that in 2002?
Your answer should be compact. 0.94. What is the ratio of the Imports (in Local Currency Unit) of Bahamas in 2001 to that in 2003?
Your response must be concise. 1.02. What is the ratio of the Imports (in Local Currency Unit) in Chile in 2001 to that in 2003?
Your response must be concise. 0.84. What is the ratio of the Imports (in Local Currency Unit) of Macedonia in 2001 to that in 2003?
Provide a succinct answer. 0.91. What is the ratio of the Imports (in Local Currency Unit) of St. Kitts and Nevis in 2001 to that in 2003?
Your response must be concise. 0.95. What is the ratio of the Imports (in Local Currency Unit) of Bahamas in 2002 to that in 2003?
Make the answer very short. 0.97. What is the ratio of the Imports (in Local Currency Unit) of Chile in 2002 to that in 2003?
Make the answer very short. 0.89. What is the ratio of the Imports (in Local Currency Unit) of St. Kitts and Nevis in 2002 to that in 2003?
Give a very brief answer. 1. What is the difference between the highest and the second highest Imports (in Local Currency Unit) in Bahamas?
Your answer should be very brief. 1.44e+08. What is the difference between the highest and the second highest Imports (in Local Currency Unit) in Chile?
Make the answer very short. 1.93e+12. What is the difference between the highest and the second highest Imports (in Local Currency Unit) of Macedonia?
Give a very brief answer. 4.31e+08. What is the difference between the highest and the second highest Imports (in Local Currency Unit) in St. Kitts and Nevis?
Offer a very short reply. 1.28e+06. What is the difference between the highest and the lowest Imports (in Local Currency Unit) of Bahamas?
Offer a terse response. 3.68e+08. What is the difference between the highest and the lowest Imports (in Local Currency Unit) in Chile?
Your answer should be compact. 6.64e+12. What is the difference between the highest and the lowest Imports (in Local Currency Unit) of Macedonia?
Your answer should be very brief. 1.07e+1. What is the difference between the highest and the lowest Imports (in Local Currency Unit) in St. Kitts and Nevis?
Provide a succinct answer. 1.71e+08. 